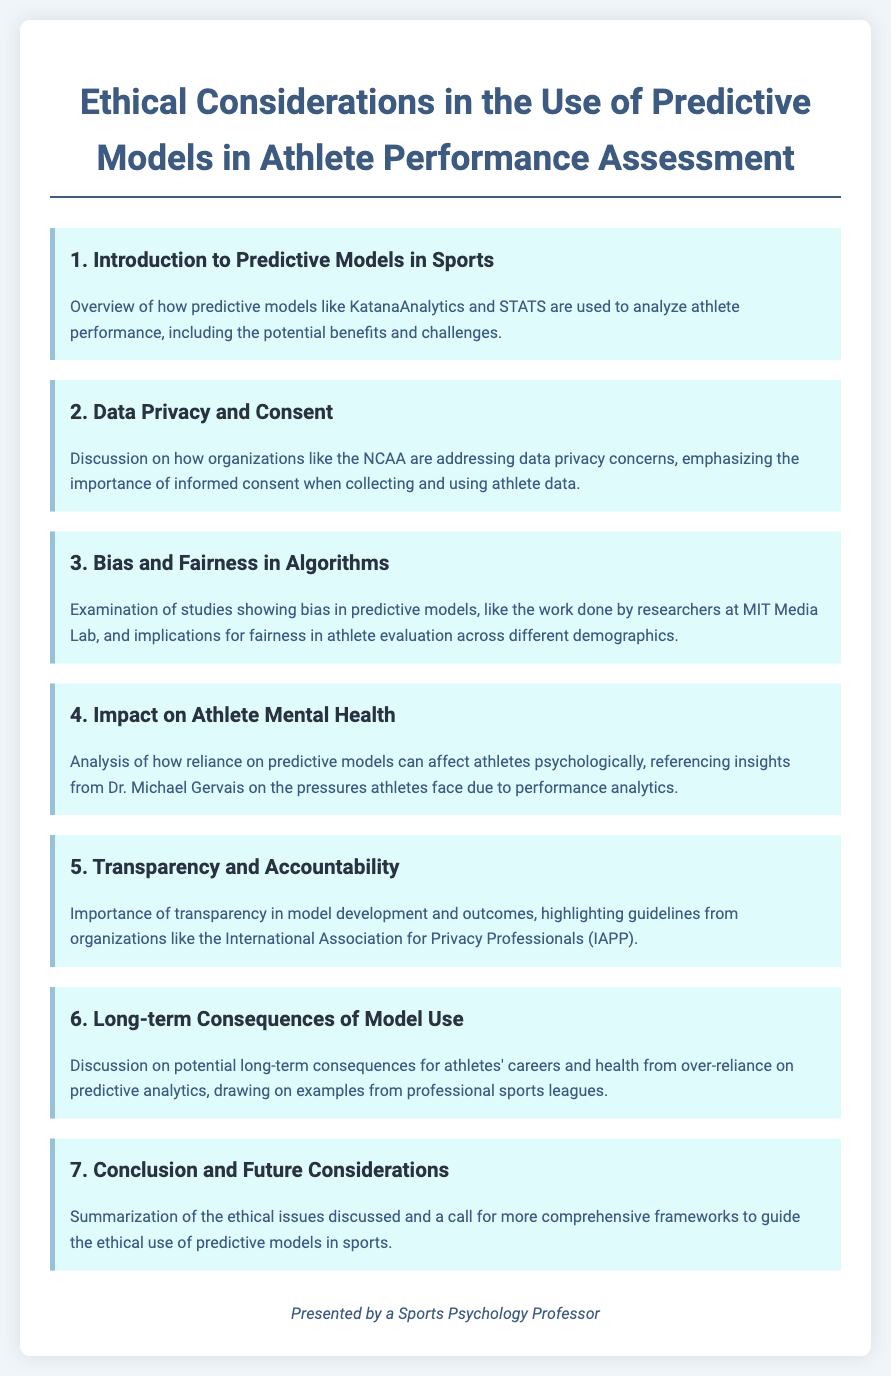What is the first agenda item? The first agenda item provides an overview of predictive models in sports, highlighting their benefits and challenges.
Answer: Introduction to Predictive Models in Sports Which organization is mentioned in relation to data privacy? The document discusses how the NCAA addresses data privacy concerns.
Answer: NCAA What is the focus of the third agenda item? The third agenda item examines bias in predictive models and its implications for fairness.
Answer: Bias and Fairness in Algorithms Who provided insights on the impact of predictive models on athletes' mental health? The document references Dr. Michael Gervais regarding the psychological effects on athletes.
Answer: Dr. Michael Gervais What is highlighted as important in the fifth agenda item? The fifth agenda item underscores the significance of transparency in model development and outcomes.
Answer: Transparency and Accountability What issue is discussed in the sixth agenda item? The sixth agenda item explores the long-term consequences of relying on predictive analytics in sports.
Answer: Long-term Consequences of Model Use 